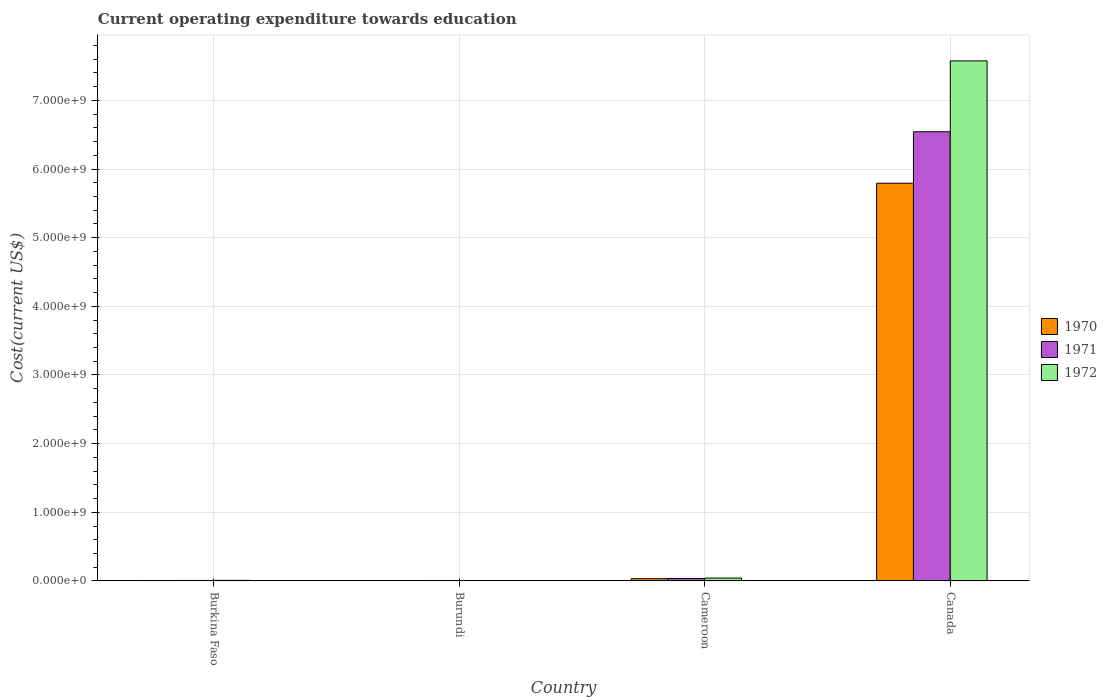Are the number of bars on each tick of the X-axis equal?
Provide a succinct answer. Yes. What is the expenditure towards education in 1972 in Cameroon?
Offer a terse response. 4.21e+07. Across all countries, what is the maximum expenditure towards education in 1972?
Provide a succinct answer. 7.58e+09. Across all countries, what is the minimum expenditure towards education in 1970?
Provide a succinct answer. 6.35e+06. In which country was the expenditure towards education in 1971 maximum?
Give a very brief answer. Canada. In which country was the expenditure towards education in 1971 minimum?
Offer a very short reply. Burundi. What is the total expenditure towards education in 1971 in the graph?
Your response must be concise. 6.59e+09. What is the difference between the expenditure towards education in 1970 in Burkina Faso and that in Cameroon?
Provide a succinct answer. -2.59e+07. What is the difference between the expenditure towards education in 1971 in Burundi and the expenditure towards education in 1972 in Canada?
Give a very brief answer. -7.57e+09. What is the average expenditure towards education in 1970 per country?
Your answer should be very brief. 1.46e+09. What is the difference between the expenditure towards education of/in 1972 and expenditure towards education of/in 1970 in Cameroon?
Make the answer very short. 9.29e+06. In how many countries, is the expenditure towards education in 1970 greater than 3600000000 US$?
Your response must be concise. 1. What is the ratio of the expenditure towards education in 1972 in Burundi to that in Canada?
Give a very brief answer. 0. Is the expenditure towards education in 1972 in Burkina Faso less than that in Burundi?
Your answer should be very brief. No. Is the difference between the expenditure towards education in 1972 in Burundi and Canada greater than the difference between the expenditure towards education in 1970 in Burundi and Canada?
Your answer should be compact. No. What is the difference between the highest and the second highest expenditure towards education in 1970?
Provide a succinct answer. 5.76e+09. What is the difference between the highest and the lowest expenditure towards education in 1972?
Give a very brief answer. 7.57e+09. What does the 2nd bar from the right in Burkina Faso represents?
Provide a succinct answer. 1971. Is it the case that in every country, the sum of the expenditure towards education in 1970 and expenditure towards education in 1971 is greater than the expenditure towards education in 1972?
Offer a very short reply. Yes. How many countries are there in the graph?
Make the answer very short. 4. Does the graph contain any zero values?
Ensure brevity in your answer.  No. Does the graph contain grids?
Give a very brief answer. Yes. How many legend labels are there?
Offer a very short reply. 3. How are the legend labels stacked?
Your answer should be very brief. Vertical. What is the title of the graph?
Provide a short and direct response. Current operating expenditure towards education. Does "1998" appear as one of the legend labels in the graph?
Offer a terse response. No. What is the label or title of the Y-axis?
Your answer should be compact. Cost(current US$). What is the Cost(current US$) in 1970 in Burkina Faso?
Keep it short and to the point. 6.88e+06. What is the Cost(current US$) of 1971 in Burkina Faso?
Offer a terse response. 7.23e+06. What is the Cost(current US$) in 1972 in Burkina Faso?
Your answer should be very brief. 8.66e+06. What is the Cost(current US$) of 1970 in Burundi?
Offer a terse response. 6.35e+06. What is the Cost(current US$) in 1971 in Burundi?
Provide a succinct answer. 6.58e+06. What is the Cost(current US$) of 1972 in Burundi?
Your response must be concise. 6.36e+06. What is the Cost(current US$) of 1970 in Cameroon?
Keep it short and to the point. 3.28e+07. What is the Cost(current US$) of 1971 in Cameroon?
Make the answer very short. 3.57e+07. What is the Cost(current US$) in 1972 in Cameroon?
Your answer should be compact. 4.21e+07. What is the Cost(current US$) in 1970 in Canada?
Offer a terse response. 5.79e+09. What is the Cost(current US$) in 1971 in Canada?
Provide a succinct answer. 6.54e+09. What is the Cost(current US$) of 1972 in Canada?
Your response must be concise. 7.58e+09. Across all countries, what is the maximum Cost(current US$) in 1970?
Keep it short and to the point. 5.79e+09. Across all countries, what is the maximum Cost(current US$) in 1971?
Offer a very short reply. 6.54e+09. Across all countries, what is the maximum Cost(current US$) of 1972?
Provide a short and direct response. 7.58e+09. Across all countries, what is the minimum Cost(current US$) of 1970?
Your answer should be very brief. 6.35e+06. Across all countries, what is the minimum Cost(current US$) of 1971?
Provide a succinct answer. 6.58e+06. Across all countries, what is the minimum Cost(current US$) of 1972?
Your answer should be compact. 6.36e+06. What is the total Cost(current US$) of 1970 in the graph?
Offer a terse response. 5.84e+09. What is the total Cost(current US$) in 1971 in the graph?
Give a very brief answer. 6.59e+09. What is the total Cost(current US$) of 1972 in the graph?
Ensure brevity in your answer.  7.63e+09. What is the difference between the Cost(current US$) of 1970 in Burkina Faso and that in Burundi?
Ensure brevity in your answer.  5.23e+05. What is the difference between the Cost(current US$) of 1971 in Burkina Faso and that in Burundi?
Your response must be concise. 6.47e+05. What is the difference between the Cost(current US$) of 1972 in Burkina Faso and that in Burundi?
Provide a short and direct response. 2.30e+06. What is the difference between the Cost(current US$) of 1970 in Burkina Faso and that in Cameroon?
Make the answer very short. -2.59e+07. What is the difference between the Cost(current US$) of 1971 in Burkina Faso and that in Cameroon?
Give a very brief answer. -2.85e+07. What is the difference between the Cost(current US$) in 1972 in Burkina Faso and that in Cameroon?
Your answer should be compact. -3.34e+07. What is the difference between the Cost(current US$) in 1970 in Burkina Faso and that in Canada?
Offer a terse response. -5.79e+09. What is the difference between the Cost(current US$) of 1971 in Burkina Faso and that in Canada?
Provide a succinct answer. -6.54e+09. What is the difference between the Cost(current US$) of 1972 in Burkina Faso and that in Canada?
Your answer should be compact. -7.57e+09. What is the difference between the Cost(current US$) in 1970 in Burundi and that in Cameroon?
Make the answer very short. -2.64e+07. What is the difference between the Cost(current US$) in 1971 in Burundi and that in Cameroon?
Your answer should be very brief. -2.91e+07. What is the difference between the Cost(current US$) of 1972 in Burundi and that in Cameroon?
Keep it short and to the point. -3.57e+07. What is the difference between the Cost(current US$) of 1970 in Burundi and that in Canada?
Provide a succinct answer. -5.79e+09. What is the difference between the Cost(current US$) in 1971 in Burundi and that in Canada?
Your response must be concise. -6.54e+09. What is the difference between the Cost(current US$) of 1972 in Burundi and that in Canada?
Ensure brevity in your answer.  -7.57e+09. What is the difference between the Cost(current US$) of 1970 in Cameroon and that in Canada?
Your answer should be very brief. -5.76e+09. What is the difference between the Cost(current US$) in 1971 in Cameroon and that in Canada?
Ensure brevity in your answer.  -6.51e+09. What is the difference between the Cost(current US$) in 1972 in Cameroon and that in Canada?
Your answer should be compact. -7.53e+09. What is the difference between the Cost(current US$) of 1970 in Burkina Faso and the Cost(current US$) of 1971 in Burundi?
Provide a succinct answer. 2.94e+05. What is the difference between the Cost(current US$) in 1970 in Burkina Faso and the Cost(current US$) in 1972 in Burundi?
Offer a very short reply. 5.20e+05. What is the difference between the Cost(current US$) in 1971 in Burkina Faso and the Cost(current US$) in 1972 in Burundi?
Give a very brief answer. 8.73e+05. What is the difference between the Cost(current US$) in 1970 in Burkina Faso and the Cost(current US$) in 1971 in Cameroon?
Make the answer very short. -2.89e+07. What is the difference between the Cost(current US$) of 1970 in Burkina Faso and the Cost(current US$) of 1972 in Cameroon?
Ensure brevity in your answer.  -3.52e+07. What is the difference between the Cost(current US$) of 1971 in Burkina Faso and the Cost(current US$) of 1972 in Cameroon?
Your answer should be compact. -3.49e+07. What is the difference between the Cost(current US$) in 1970 in Burkina Faso and the Cost(current US$) in 1971 in Canada?
Provide a short and direct response. -6.54e+09. What is the difference between the Cost(current US$) of 1970 in Burkina Faso and the Cost(current US$) of 1972 in Canada?
Provide a short and direct response. -7.57e+09. What is the difference between the Cost(current US$) of 1971 in Burkina Faso and the Cost(current US$) of 1972 in Canada?
Keep it short and to the point. -7.57e+09. What is the difference between the Cost(current US$) in 1970 in Burundi and the Cost(current US$) in 1971 in Cameroon?
Your answer should be very brief. -2.94e+07. What is the difference between the Cost(current US$) in 1970 in Burundi and the Cost(current US$) in 1972 in Cameroon?
Keep it short and to the point. -3.57e+07. What is the difference between the Cost(current US$) in 1971 in Burundi and the Cost(current US$) in 1972 in Cameroon?
Your answer should be compact. -3.55e+07. What is the difference between the Cost(current US$) of 1970 in Burundi and the Cost(current US$) of 1971 in Canada?
Ensure brevity in your answer.  -6.54e+09. What is the difference between the Cost(current US$) in 1970 in Burundi and the Cost(current US$) in 1972 in Canada?
Ensure brevity in your answer.  -7.57e+09. What is the difference between the Cost(current US$) of 1971 in Burundi and the Cost(current US$) of 1972 in Canada?
Keep it short and to the point. -7.57e+09. What is the difference between the Cost(current US$) of 1970 in Cameroon and the Cost(current US$) of 1971 in Canada?
Your answer should be very brief. -6.51e+09. What is the difference between the Cost(current US$) of 1970 in Cameroon and the Cost(current US$) of 1972 in Canada?
Provide a short and direct response. -7.54e+09. What is the difference between the Cost(current US$) in 1971 in Cameroon and the Cost(current US$) in 1972 in Canada?
Give a very brief answer. -7.54e+09. What is the average Cost(current US$) of 1970 per country?
Give a very brief answer. 1.46e+09. What is the average Cost(current US$) in 1971 per country?
Provide a succinct answer. 1.65e+09. What is the average Cost(current US$) in 1972 per country?
Provide a succinct answer. 1.91e+09. What is the difference between the Cost(current US$) in 1970 and Cost(current US$) in 1971 in Burkina Faso?
Your answer should be compact. -3.53e+05. What is the difference between the Cost(current US$) in 1970 and Cost(current US$) in 1972 in Burkina Faso?
Give a very brief answer. -1.78e+06. What is the difference between the Cost(current US$) in 1971 and Cost(current US$) in 1972 in Burkina Faso?
Offer a very short reply. -1.43e+06. What is the difference between the Cost(current US$) in 1970 and Cost(current US$) in 1971 in Burundi?
Your answer should be compact. -2.29e+05. What is the difference between the Cost(current US$) of 1970 and Cost(current US$) of 1972 in Burundi?
Offer a terse response. -3332.57. What is the difference between the Cost(current US$) of 1971 and Cost(current US$) of 1972 in Burundi?
Ensure brevity in your answer.  2.26e+05. What is the difference between the Cost(current US$) in 1970 and Cost(current US$) in 1971 in Cameroon?
Make the answer very short. -2.94e+06. What is the difference between the Cost(current US$) of 1970 and Cost(current US$) of 1972 in Cameroon?
Provide a short and direct response. -9.29e+06. What is the difference between the Cost(current US$) in 1971 and Cost(current US$) in 1972 in Cameroon?
Provide a succinct answer. -6.35e+06. What is the difference between the Cost(current US$) in 1970 and Cost(current US$) in 1971 in Canada?
Provide a succinct answer. -7.50e+08. What is the difference between the Cost(current US$) of 1970 and Cost(current US$) of 1972 in Canada?
Your response must be concise. -1.78e+09. What is the difference between the Cost(current US$) in 1971 and Cost(current US$) in 1972 in Canada?
Your answer should be compact. -1.03e+09. What is the ratio of the Cost(current US$) of 1970 in Burkina Faso to that in Burundi?
Keep it short and to the point. 1.08. What is the ratio of the Cost(current US$) in 1971 in Burkina Faso to that in Burundi?
Make the answer very short. 1.1. What is the ratio of the Cost(current US$) in 1972 in Burkina Faso to that in Burundi?
Keep it short and to the point. 1.36. What is the ratio of the Cost(current US$) of 1970 in Burkina Faso to that in Cameroon?
Provide a succinct answer. 0.21. What is the ratio of the Cost(current US$) of 1971 in Burkina Faso to that in Cameroon?
Offer a very short reply. 0.2. What is the ratio of the Cost(current US$) in 1972 in Burkina Faso to that in Cameroon?
Keep it short and to the point. 0.21. What is the ratio of the Cost(current US$) in 1970 in Burkina Faso to that in Canada?
Provide a short and direct response. 0. What is the ratio of the Cost(current US$) in 1971 in Burkina Faso to that in Canada?
Provide a succinct answer. 0. What is the ratio of the Cost(current US$) of 1972 in Burkina Faso to that in Canada?
Offer a very short reply. 0. What is the ratio of the Cost(current US$) in 1970 in Burundi to that in Cameroon?
Offer a terse response. 0.19. What is the ratio of the Cost(current US$) in 1971 in Burundi to that in Cameroon?
Your response must be concise. 0.18. What is the ratio of the Cost(current US$) in 1972 in Burundi to that in Cameroon?
Your answer should be compact. 0.15. What is the ratio of the Cost(current US$) of 1970 in Burundi to that in Canada?
Keep it short and to the point. 0. What is the ratio of the Cost(current US$) of 1972 in Burundi to that in Canada?
Offer a terse response. 0. What is the ratio of the Cost(current US$) in 1970 in Cameroon to that in Canada?
Offer a terse response. 0.01. What is the ratio of the Cost(current US$) in 1971 in Cameroon to that in Canada?
Your answer should be very brief. 0.01. What is the ratio of the Cost(current US$) in 1972 in Cameroon to that in Canada?
Your answer should be compact. 0.01. What is the difference between the highest and the second highest Cost(current US$) in 1970?
Your answer should be very brief. 5.76e+09. What is the difference between the highest and the second highest Cost(current US$) in 1971?
Keep it short and to the point. 6.51e+09. What is the difference between the highest and the second highest Cost(current US$) of 1972?
Your answer should be compact. 7.53e+09. What is the difference between the highest and the lowest Cost(current US$) in 1970?
Give a very brief answer. 5.79e+09. What is the difference between the highest and the lowest Cost(current US$) in 1971?
Make the answer very short. 6.54e+09. What is the difference between the highest and the lowest Cost(current US$) in 1972?
Offer a terse response. 7.57e+09. 